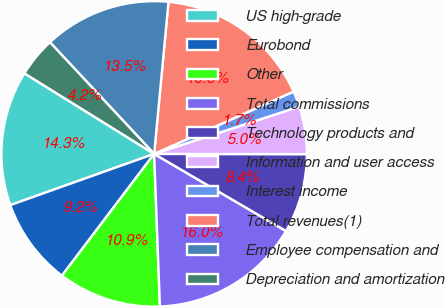Convert chart. <chart><loc_0><loc_0><loc_500><loc_500><pie_chart><fcel>US high-grade<fcel>Eurobond<fcel>Other<fcel>Total commissions<fcel>Technology products and<fcel>Information and user access<fcel>Interest income<fcel>Total revenues(1)<fcel>Employee compensation and<fcel>Depreciation and amortization<nl><fcel>14.29%<fcel>9.24%<fcel>10.92%<fcel>15.97%<fcel>8.4%<fcel>5.04%<fcel>1.68%<fcel>16.81%<fcel>13.45%<fcel>4.2%<nl></chart> 